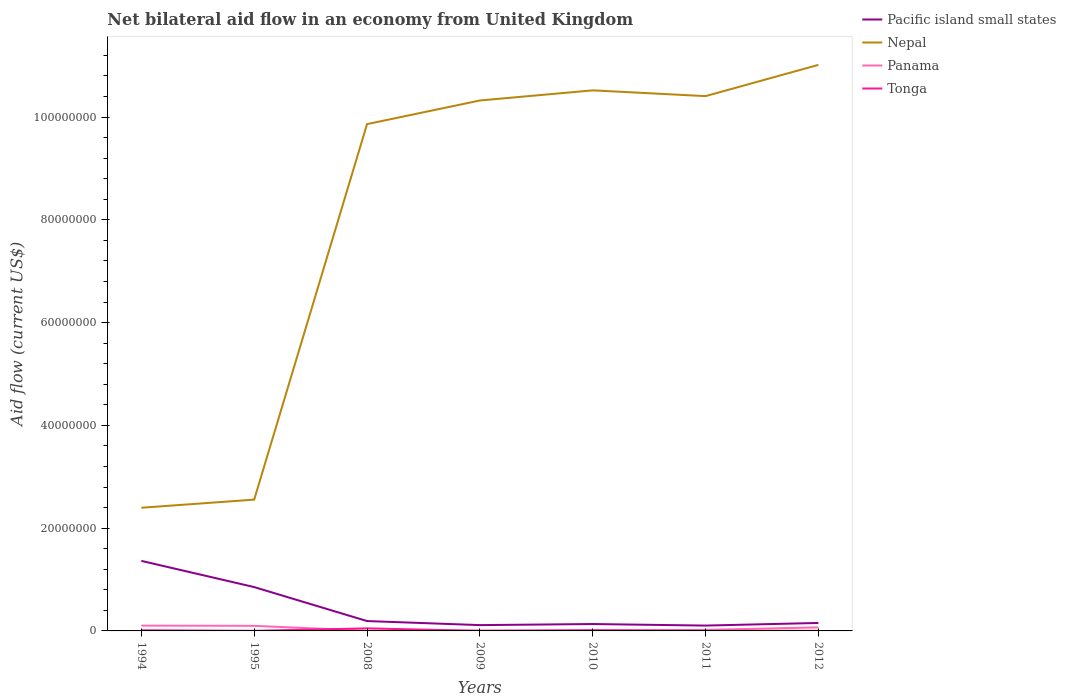Is the number of lines equal to the number of legend labels?
Provide a short and direct response. Yes. Across all years, what is the maximum net bilateral aid flow in Nepal?
Your answer should be compact. 2.40e+07. What is the total net bilateral aid flow in Tonga in the graph?
Ensure brevity in your answer.  4.90e+05. Is the net bilateral aid flow in Panama strictly greater than the net bilateral aid flow in Nepal over the years?
Make the answer very short. Yes. How many years are there in the graph?
Provide a short and direct response. 7. Does the graph contain any zero values?
Provide a short and direct response. No. Does the graph contain grids?
Your answer should be very brief. No. How many legend labels are there?
Your response must be concise. 4. What is the title of the graph?
Offer a terse response. Net bilateral aid flow in an economy from United Kingdom. What is the label or title of the Y-axis?
Ensure brevity in your answer.  Aid flow (current US$). What is the Aid flow (current US$) of Pacific island small states in 1994?
Your response must be concise. 1.36e+07. What is the Aid flow (current US$) of Nepal in 1994?
Give a very brief answer. 2.40e+07. What is the Aid flow (current US$) of Panama in 1994?
Give a very brief answer. 1.03e+06. What is the Aid flow (current US$) of Pacific island small states in 1995?
Your response must be concise. 8.53e+06. What is the Aid flow (current US$) of Nepal in 1995?
Provide a short and direct response. 2.56e+07. What is the Aid flow (current US$) in Panama in 1995?
Offer a very short reply. 9.90e+05. What is the Aid flow (current US$) in Tonga in 1995?
Make the answer very short. 2.00e+04. What is the Aid flow (current US$) of Pacific island small states in 2008?
Ensure brevity in your answer.  1.92e+06. What is the Aid flow (current US$) of Nepal in 2008?
Make the answer very short. 9.86e+07. What is the Aid flow (current US$) in Pacific island small states in 2009?
Your answer should be compact. 1.13e+06. What is the Aid flow (current US$) of Nepal in 2009?
Ensure brevity in your answer.  1.03e+08. What is the Aid flow (current US$) of Panama in 2009?
Ensure brevity in your answer.  7.00e+04. What is the Aid flow (current US$) in Tonga in 2009?
Provide a short and direct response. 10000. What is the Aid flow (current US$) in Pacific island small states in 2010?
Give a very brief answer. 1.34e+06. What is the Aid flow (current US$) of Nepal in 2010?
Provide a short and direct response. 1.05e+08. What is the Aid flow (current US$) of Panama in 2010?
Provide a succinct answer. 4.00e+04. What is the Aid flow (current US$) of Tonga in 2010?
Your answer should be very brief. 1.50e+05. What is the Aid flow (current US$) in Pacific island small states in 2011?
Offer a terse response. 1.04e+06. What is the Aid flow (current US$) of Nepal in 2011?
Offer a terse response. 1.04e+08. What is the Aid flow (current US$) of Tonga in 2011?
Make the answer very short. 3.00e+04. What is the Aid flow (current US$) in Pacific island small states in 2012?
Provide a succinct answer. 1.55e+06. What is the Aid flow (current US$) in Nepal in 2012?
Your answer should be very brief. 1.10e+08. What is the Aid flow (current US$) of Panama in 2012?
Offer a very short reply. 6.90e+05. What is the Aid flow (current US$) of Tonga in 2012?
Keep it short and to the point. 3.00e+04. Across all years, what is the maximum Aid flow (current US$) in Pacific island small states?
Keep it short and to the point. 1.36e+07. Across all years, what is the maximum Aid flow (current US$) of Nepal?
Ensure brevity in your answer.  1.10e+08. Across all years, what is the maximum Aid flow (current US$) in Panama?
Your response must be concise. 1.03e+06. Across all years, what is the maximum Aid flow (current US$) in Tonga?
Offer a terse response. 5.00e+05. Across all years, what is the minimum Aid flow (current US$) of Pacific island small states?
Offer a terse response. 1.04e+06. Across all years, what is the minimum Aid flow (current US$) of Nepal?
Your response must be concise. 2.40e+07. Across all years, what is the minimum Aid flow (current US$) in Panama?
Offer a very short reply. 4.00e+04. What is the total Aid flow (current US$) of Pacific island small states in the graph?
Provide a succinct answer. 2.91e+07. What is the total Aid flow (current US$) in Nepal in the graph?
Offer a very short reply. 5.71e+08. What is the total Aid flow (current US$) of Panama in the graph?
Your answer should be very brief. 3.06e+06. What is the total Aid flow (current US$) of Tonga in the graph?
Provide a succinct answer. 8.70e+05. What is the difference between the Aid flow (current US$) in Pacific island small states in 1994 and that in 1995?
Ensure brevity in your answer.  5.10e+06. What is the difference between the Aid flow (current US$) in Nepal in 1994 and that in 1995?
Your response must be concise. -1.58e+06. What is the difference between the Aid flow (current US$) of Pacific island small states in 1994 and that in 2008?
Make the answer very short. 1.17e+07. What is the difference between the Aid flow (current US$) in Nepal in 1994 and that in 2008?
Offer a very short reply. -7.46e+07. What is the difference between the Aid flow (current US$) of Panama in 1994 and that in 2008?
Provide a short and direct response. 9.90e+05. What is the difference between the Aid flow (current US$) of Tonga in 1994 and that in 2008?
Your answer should be compact. -3.70e+05. What is the difference between the Aid flow (current US$) in Pacific island small states in 1994 and that in 2009?
Ensure brevity in your answer.  1.25e+07. What is the difference between the Aid flow (current US$) in Nepal in 1994 and that in 2009?
Your answer should be compact. -7.92e+07. What is the difference between the Aid flow (current US$) of Panama in 1994 and that in 2009?
Give a very brief answer. 9.60e+05. What is the difference between the Aid flow (current US$) in Pacific island small states in 1994 and that in 2010?
Your answer should be very brief. 1.23e+07. What is the difference between the Aid flow (current US$) in Nepal in 1994 and that in 2010?
Make the answer very short. -8.12e+07. What is the difference between the Aid flow (current US$) of Panama in 1994 and that in 2010?
Make the answer very short. 9.90e+05. What is the difference between the Aid flow (current US$) of Tonga in 1994 and that in 2010?
Your response must be concise. -2.00e+04. What is the difference between the Aid flow (current US$) of Pacific island small states in 1994 and that in 2011?
Ensure brevity in your answer.  1.26e+07. What is the difference between the Aid flow (current US$) in Nepal in 1994 and that in 2011?
Offer a terse response. -8.01e+07. What is the difference between the Aid flow (current US$) of Panama in 1994 and that in 2011?
Offer a very short reply. 8.30e+05. What is the difference between the Aid flow (current US$) of Tonga in 1994 and that in 2011?
Ensure brevity in your answer.  1.00e+05. What is the difference between the Aid flow (current US$) of Pacific island small states in 1994 and that in 2012?
Provide a succinct answer. 1.21e+07. What is the difference between the Aid flow (current US$) in Nepal in 1994 and that in 2012?
Your answer should be compact. -8.62e+07. What is the difference between the Aid flow (current US$) in Pacific island small states in 1995 and that in 2008?
Provide a succinct answer. 6.61e+06. What is the difference between the Aid flow (current US$) in Nepal in 1995 and that in 2008?
Provide a short and direct response. -7.31e+07. What is the difference between the Aid flow (current US$) of Panama in 1995 and that in 2008?
Make the answer very short. 9.50e+05. What is the difference between the Aid flow (current US$) in Tonga in 1995 and that in 2008?
Ensure brevity in your answer.  -4.80e+05. What is the difference between the Aid flow (current US$) in Pacific island small states in 1995 and that in 2009?
Keep it short and to the point. 7.40e+06. What is the difference between the Aid flow (current US$) of Nepal in 1995 and that in 2009?
Make the answer very short. -7.77e+07. What is the difference between the Aid flow (current US$) in Panama in 1995 and that in 2009?
Keep it short and to the point. 9.20e+05. What is the difference between the Aid flow (current US$) in Pacific island small states in 1995 and that in 2010?
Your answer should be compact. 7.19e+06. What is the difference between the Aid flow (current US$) in Nepal in 1995 and that in 2010?
Provide a succinct answer. -7.96e+07. What is the difference between the Aid flow (current US$) in Panama in 1995 and that in 2010?
Give a very brief answer. 9.50e+05. What is the difference between the Aid flow (current US$) of Tonga in 1995 and that in 2010?
Offer a very short reply. -1.30e+05. What is the difference between the Aid flow (current US$) of Pacific island small states in 1995 and that in 2011?
Your response must be concise. 7.49e+06. What is the difference between the Aid flow (current US$) of Nepal in 1995 and that in 2011?
Your answer should be very brief. -7.85e+07. What is the difference between the Aid flow (current US$) in Panama in 1995 and that in 2011?
Your answer should be compact. 7.90e+05. What is the difference between the Aid flow (current US$) in Pacific island small states in 1995 and that in 2012?
Make the answer very short. 6.98e+06. What is the difference between the Aid flow (current US$) in Nepal in 1995 and that in 2012?
Offer a terse response. -8.46e+07. What is the difference between the Aid flow (current US$) in Panama in 1995 and that in 2012?
Offer a very short reply. 3.00e+05. What is the difference between the Aid flow (current US$) in Tonga in 1995 and that in 2012?
Provide a succinct answer. -10000. What is the difference between the Aid flow (current US$) of Pacific island small states in 2008 and that in 2009?
Your response must be concise. 7.90e+05. What is the difference between the Aid flow (current US$) of Nepal in 2008 and that in 2009?
Your answer should be compact. -4.60e+06. What is the difference between the Aid flow (current US$) in Tonga in 2008 and that in 2009?
Keep it short and to the point. 4.90e+05. What is the difference between the Aid flow (current US$) in Pacific island small states in 2008 and that in 2010?
Give a very brief answer. 5.80e+05. What is the difference between the Aid flow (current US$) in Nepal in 2008 and that in 2010?
Keep it short and to the point. -6.57e+06. What is the difference between the Aid flow (current US$) in Tonga in 2008 and that in 2010?
Offer a terse response. 3.50e+05. What is the difference between the Aid flow (current US$) in Pacific island small states in 2008 and that in 2011?
Offer a very short reply. 8.80e+05. What is the difference between the Aid flow (current US$) in Nepal in 2008 and that in 2011?
Provide a succinct answer. -5.45e+06. What is the difference between the Aid flow (current US$) in Nepal in 2008 and that in 2012?
Provide a succinct answer. -1.15e+07. What is the difference between the Aid flow (current US$) in Panama in 2008 and that in 2012?
Give a very brief answer. -6.50e+05. What is the difference between the Aid flow (current US$) in Pacific island small states in 2009 and that in 2010?
Keep it short and to the point. -2.10e+05. What is the difference between the Aid flow (current US$) in Nepal in 2009 and that in 2010?
Your answer should be very brief. -1.97e+06. What is the difference between the Aid flow (current US$) in Pacific island small states in 2009 and that in 2011?
Ensure brevity in your answer.  9.00e+04. What is the difference between the Aid flow (current US$) of Nepal in 2009 and that in 2011?
Your response must be concise. -8.50e+05. What is the difference between the Aid flow (current US$) in Panama in 2009 and that in 2011?
Offer a terse response. -1.30e+05. What is the difference between the Aid flow (current US$) of Tonga in 2009 and that in 2011?
Make the answer very short. -2.00e+04. What is the difference between the Aid flow (current US$) of Pacific island small states in 2009 and that in 2012?
Keep it short and to the point. -4.20e+05. What is the difference between the Aid flow (current US$) of Nepal in 2009 and that in 2012?
Your response must be concise. -6.93e+06. What is the difference between the Aid flow (current US$) in Panama in 2009 and that in 2012?
Keep it short and to the point. -6.20e+05. What is the difference between the Aid flow (current US$) of Tonga in 2009 and that in 2012?
Offer a very short reply. -2.00e+04. What is the difference between the Aid flow (current US$) of Nepal in 2010 and that in 2011?
Your answer should be compact. 1.12e+06. What is the difference between the Aid flow (current US$) in Panama in 2010 and that in 2011?
Keep it short and to the point. -1.60e+05. What is the difference between the Aid flow (current US$) in Tonga in 2010 and that in 2011?
Make the answer very short. 1.20e+05. What is the difference between the Aid flow (current US$) of Pacific island small states in 2010 and that in 2012?
Offer a very short reply. -2.10e+05. What is the difference between the Aid flow (current US$) of Nepal in 2010 and that in 2012?
Your answer should be compact. -4.96e+06. What is the difference between the Aid flow (current US$) of Panama in 2010 and that in 2012?
Provide a succinct answer. -6.50e+05. What is the difference between the Aid flow (current US$) in Pacific island small states in 2011 and that in 2012?
Give a very brief answer. -5.10e+05. What is the difference between the Aid flow (current US$) of Nepal in 2011 and that in 2012?
Make the answer very short. -6.08e+06. What is the difference between the Aid flow (current US$) in Panama in 2011 and that in 2012?
Ensure brevity in your answer.  -4.90e+05. What is the difference between the Aid flow (current US$) of Tonga in 2011 and that in 2012?
Offer a terse response. 0. What is the difference between the Aid flow (current US$) of Pacific island small states in 1994 and the Aid flow (current US$) of Nepal in 1995?
Give a very brief answer. -1.19e+07. What is the difference between the Aid flow (current US$) in Pacific island small states in 1994 and the Aid flow (current US$) in Panama in 1995?
Make the answer very short. 1.26e+07. What is the difference between the Aid flow (current US$) of Pacific island small states in 1994 and the Aid flow (current US$) of Tonga in 1995?
Keep it short and to the point. 1.36e+07. What is the difference between the Aid flow (current US$) of Nepal in 1994 and the Aid flow (current US$) of Panama in 1995?
Provide a short and direct response. 2.30e+07. What is the difference between the Aid flow (current US$) in Nepal in 1994 and the Aid flow (current US$) in Tonga in 1995?
Make the answer very short. 2.40e+07. What is the difference between the Aid flow (current US$) in Panama in 1994 and the Aid flow (current US$) in Tonga in 1995?
Offer a terse response. 1.01e+06. What is the difference between the Aid flow (current US$) in Pacific island small states in 1994 and the Aid flow (current US$) in Nepal in 2008?
Offer a terse response. -8.50e+07. What is the difference between the Aid flow (current US$) in Pacific island small states in 1994 and the Aid flow (current US$) in Panama in 2008?
Your answer should be very brief. 1.36e+07. What is the difference between the Aid flow (current US$) in Pacific island small states in 1994 and the Aid flow (current US$) in Tonga in 2008?
Give a very brief answer. 1.31e+07. What is the difference between the Aid flow (current US$) in Nepal in 1994 and the Aid flow (current US$) in Panama in 2008?
Make the answer very short. 2.39e+07. What is the difference between the Aid flow (current US$) in Nepal in 1994 and the Aid flow (current US$) in Tonga in 2008?
Offer a very short reply. 2.35e+07. What is the difference between the Aid flow (current US$) of Panama in 1994 and the Aid flow (current US$) of Tonga in 2008?
Make the answer very short. 5.30e+05. What is the difference between the Aid flow (current US$) of Pacific island small states in 1994 and the Aid flow (current US$) of Nepal in 2009?
Your answer should be very brief. -8.96e+07. What is the difference between the Aid flow (current US$) of Pacific island small states in 1994 and the Aid flow (current US$) of Panama in 2009?
Ensure brevity in your answer.  1.36e+07. What is the difference between the Aid flow (current US$) in Pacific island small states in 1994 and the Aid flow (current US$) in Tonga in 2009?
Your answer should be very brief. 1.36e+07. What is the difference between the Aid flow (current US$) in Nepal in 1994 and the Aid flow (current US$) in Panama in 2009?
Ensure brevity in your answer.  2.39e+07. What is the difference between the Aid flow (current US$) of Nepal in 1994 and the Aid flow (current US$) of Tonga in 2009?
Your answer should be very brief. 2.40e+07. What is the difference between the Aid flow (current US$) in Panama in 1994 and the Aid flow (current US$) in Tonga in 2009?
Give a very brief answer. 1.02e+06. What is the difference between the Aid flow (current US$) of Pacific island small states in 1994 and the Aid flow (current US$) of Nepal in 2010?
Keep it short and to the point. -9.16e+07. What is the difference between the Aid flow (current US$) of Pacific island small states in 1994 and the Aid flow (current US$) of Panama in 2010?
Provide a succinct answer. 1.36e+07. What is the difference between the Aid flow (current US$) of Pacific island small states in 1994 and the Aid flow (current US$) of Tonga in 2010?
Your response must be concise. 1.35e+07. What is the difference between the Aid flow (current US$) of Nepal in 1994 and the Aid flow (current US$) of Panama in 2010?
Provide a succinct answer. 2.39e+07. What is the difference between the Aid flow (current US$) of Nepal in 1994 and the Aid flow (current US$) of Tonga in 2010?
Offer a very short reply. 2.38e+07. What is the difference between the Aid flow (current US$) of Panama in 1994 and the Aid flow (current US$) of Tonga in 2010?
Make the answer very short. 8.80e+05. What is the difference between the Aid flow (current US$) of Pacific island small states in 1994 and the Aid flow (current US$) of Nepal in 2011?
Provide a succinct answer. -9.04e+07. What is the difference between the Aid flow (current US$) in Pacific island small states in 1994 and the Aid flow (current US$) in Panama in 2011?
Keep it short and to the point. 1.34e+07. What is the difference between the Aid flow (current US$) of Pacific island small states in 1994 and the Aid flow (current US$) of Tonga in 2011?
Provide a succinct answer. 1.36e+07. What is the difference between the Aid flow (current US$) in Nepal in 1994 and the Aid flow (current US$) in Panama in 2011?
Provide a short and direct response. 2.38e+07. What is the difference between the Aid flow (current US$) in Nepal in 1994 and the Aid flow (current US$) in Tonga in 2011?
Provide a succinct answer. 2.39e+07. What is the difference between the Aid flow (current US$) in Pacific island small states in 1994 and the Aid flow (current US$) in Nepal in 2012?
Offer a terse response. -9.65e+07. What is the difference between the Aid flow (current US$) in Pacific island small states in 1994 and the Aid flow (current US$) in Panama in 2012?
Provide a succinct answer. 1.29e+07. What is the difference between the Aid flow (current US$) in Pacific island small states in 1994 and the Aid flow (current US$) in Tonga in 2012?
Offer a very short reply. 1.36e+07. What is the difference between the Aid flow (current US$) in Nepal in 1994 and the Aid flow (current US$) in Panama in 2012?
Keep it short and to the point. 2.33e+07. What is the difference between the Aid flow (current US$) in Nepal in 1994 and the Aid flow (current US$) in Tonga in 2012?
Offer a very short reply. 2.39e+07. What is the difference between the Aid flow (current US$) in Pacific island small states in 1995 and the Aid flow (current US$) in Nepal in 2008?
Offer a terse response. -9.01e+07. What is the difference between the Aid flow (current US$) in Pacific island small states in 1995 and the Aid flow (current US$) in Panama in 2008?
Offer a very short reply. 8.49e+06. What is the difference between the Aid flow (current US$) in Pacific island small states in 1995 and the Aid flow (current US$) in Tonga in 2008?
Give a very brief answer. 8.03e+06. What is the difference between the Aid flow (current US$) in Nepal in 1995 and the Aid flow (current US$) in Panama in 2008?
Provide a short and direct response. 2.55e+07. What is the difference between the Aid flow (current US$) in Nepal in 1995 and the Aid flow (current US$) in Tonga in 2008?
Offer a very short reply. 2.50e+07. What is the difference between the Aid flow (current US$) in Pacific island small states in 1995 and the Aid flow (current US$) in Nepal in 2009?
Provide a short and direct response. -9.47e+07. What is the difference between the Aid flow (current US$) of Pacific island small states in 1995 and the Aid flow (current US$) of Panama in 2009?
Offer a terse response. 8.46e+06. What is the difference between the Aid flow (current US$) of Pacific island small states in 1995 and the Aid flow (current US$) of Tonga in 2009?
Provide a succinct answer. 8.52e+06. What is the difference between the Aid flow (current US$) in Nepal in 1995 and the Aid flow (current US$) in Panama in 2009?
Make the answer very short. 2.55e+07. What is the difference between the Aid flow (current US$) in Nepal in 1995 and the Aid flow (current US$) in Tonga in 2009?
Your answer should be compact. 2.55e+07. What is the difference between the Aid flow (current US$) of Panama in 1995 and the Aid flow (current US$) of Tonga in 2009?
Offer a very short reply. 9.80e+05. What is the difference between the Aid flow (current US$) of Pacific island small states in 1995 and the Aid flow (current US$) of Nepal in 2010?
Your response must be concise. -9.67e+07. What is the difference between the Aid flow (current US$) in Pacific island small states in 1995 and the Aid flow (current US$) in Panama in 2010?
Your response must be concise. 8.49e+06. What is the difference between the Aid flow (current US$) of Pacific island small states in 1995 and the Aid flow (current US$) of Tonga in 2010?
Give a very brief answer. 8.38e+06. What is the difference between the Aid flow (current US$) in Nepal in 1995 and the Aid flow (current US$) in Panama in 2010?
Offer a very short reply. 2.55e+07. What is the difference between the Aid flow (current US$) of Nepal in 1995 and the Aid flow (current US$) of Tonga in 2010?
Provide a short and direct response. 2.54e+07. What is the difference between the Aid flow (current US$) of Panama in 1995 and the Aid flow (current US$) of Tonga in 2010?
Ensure brevity in your answer.  8.40e+05. What is the difference between the Aid flow (current US$) of Pacific island small states in 1995 and the Aid flow (current US$) of Nepal in 2011?
Offer a terse response. -9.55e+07. What is the difference between the Aid flow (current US$) in Pacific island small states in 1995 and the Aid flow (current US$) in Panama in 2011?
Give a very brief answer. 8.33e+06. What is the difference between the Aid flow (current US$) of Pacific island small states in 1995 and the Aid flow (current US$) of Tonga in 2011?
Make the answer very short. 8.50e+06. What is the difference between the Aid flow (current US$) of Nepal in 1995 and the Aid flow (current US$) of Panama in 2011?
Keep it short and to the point. 2.54e+07. What is the difference between the Aid flow (current US$) in Nepal in 1995 and the Aid flow (current US$) in Tonga in 2011?
Offer a very short reply. 2.55e+07. What is the difference between the Aid flow (current US$) in Panama in 1995 and the Aid flow (current US$) in Tonga in 2011?
Your answer should be compact. 9.60e+05. What is the difference between the Aid flow (current US$) of Pacific island small states in 1995 and the Aid flow (current US$) of Nepal in 2012?
Offer a very short reply. -1.02e+08. What is the difference between the Aid flow (current US$) of Pacific island small states in 1995 and the Aid flow (current US$) of Panama in 2012?
Provide a short and direct response. 7.84e+06. What is the difference between the Aid flow (current US$) in Pacific island small states in 1995 and the Aid flow (current US$) in Tonga in 2012?
Make the answer very short. 8.50e+06. What is the difference between the Aid flow (current US$) in Nepal in 1995 and the Aid flow (current US$) in Panama in 2012?
Offer a very short reply. 2.49e+07. What is the difference between the Aid flow (current US$) of Nepal in 1995 and the Aid flow (current US$) of Tonga in 2012?
Your response must be concise. 2.55e+07. What is the difference between the Aid flow (current US$) of Panama in 1995 and the Aid flow (current US$) of Tonga in 2012?
Offer a very short reply. 9.60e+05. What is the difference between the Aid flow (current US$) in Pacific island small states in 2008 and the Aid flow (current US$) in Nepal in 2009?
Keep it short and to the point. -1.01e+08. What is the difference between the Aid flow (current US$) of Pacific island small states in 2008 and the Aid flow (current US$) of Panama in 2009?
Your answer should be very brief. 1.85e+06. What is the difference between the Aid flow (current US$) in Pacific island small states in 2008 and the Aid flow (current US$) in Tonga in 2009?
Make the answer very short. 1.91e+06. What is the difference between the Aid flow (current US$) of Nepal in 2008 and the Aid flow (current US$) of Panama in 2009?
Your response must be concise. 9.86e+07. What is the difference between the Aid flow (current US$) in Nepal in 2008 and the Aid flow (current US$) in Tonga in 2009?
Your answer should be compact. 9.86e+07. What is the difference between the Aid flow (current US$) in Panama in 2008 and the Aid flow (current US$) in Tonga in 2009?
Provide a succinct answer. 3.00e+04. What is the difference between the Aid flow (current US$) in Pacific island small states in 2008 and the Aid flow (current US$) in Nepal in 2010?
Provide a short and direct response. -1.03e+08. What is the difference between the Aid flow (current US$) of Pacific island small states in 2008 and the Aid flow (current US$) of Panama in 2010?
Keep it short and to the point. 1.88e+06. What is the difference between the Aid flow (current US$) of Pacific island small states in 2008 and the Aid flow (current US$) of Tonga in 2010?
Your response must be concise. 1.77e+06. What is the difference between the Aid flow (current US$) in Nepal in 2008 and the Aid flow (current US$) in Panama in 2010?
Your answer should be compact. 9.86e+07. What is the difference between the Aid flow (current US$) of Nepal in 2008 and the Aid flow (current US$) of Tonga in 2010?
Your response must be concise. 9.85e+07. What is the difference between the Aid flow (current US$) in Panama in 2008 and the Aid flow (current US$) in Tonga in 2010?
Offer a terse response. -1.10e+05. What is the difference between the Aid flow (current US$) of Pacific island small states in 2008 and the Aid flow (current US$) of Nepal in 2011?
Make the answer very short. -1.02e+08. What is the difference between the Aid flow (current US$) in Pacific island small states in 2008 and the Aid flow (current US$) in Panama in 2011?
Offer a very short reply. 1.72e+06. What is the difference between the Aid flow (current US$) of Pacific island small states in 2008 and the Aid flow (current US$) of Tonga in 2011?
Offer a very short reply. 1.89e+06. What is the difference between the Aid flow (current US$) in Nepal in 2008 and the Aid flow (current US$) in Panama in 2011?
Your answer should be very brief. 9.84e+07. What is the difference between the Aid flow (current US$) of Nepal in 2008 and the Aid flow (current US$) of Tonga in 2011?
Your answer should be very brief. 9.86e+07. What is the difference between the Aid flow (current US$) of Panama in 2008 and the Aid flow (current US$) of Tonga in 2011?
Your response must be concise. 10000. What is the difference between the Aid flow (current US$) of Pacific island small states in 2008 and the Aid flow (current US$) of Nepal in 2012?
Your response must be concise. -1.08e+08. What is the difference between the Aid flow (current US$) in Pacific island small states in 2008 and the Aid flow (current US$) in Panama in 2012?
Your answer should be very brief. 1.23e+06. What is the difference between the Aid flow (current US$) in Pacific island small states in 2008 and the Aid flow (current US$) in Tonga in 2012?
Provide a succinct answer. 1.89e+06. What is the difference between the Aid flow (current US$) in Nepal in 2008 and the Aid flow (current US$) in Panama in 2012?
Give a very brief answer. 9.79e+07. What is the difference between the Aid flow (current US$) of Nepal in 2008 and the Aid flow (current US$) of Tonga in 2012?
Provide a short and direct response. 9.86e+07. What is the difference between the Aid flow (current US$) of Pacific island small states in 2009 and the Aid flow (current US$) of Nepal in 2010?
Keep it short and to the point. -1.04e+08. What is the difference between the Aid flow (current US$) of Pacific island small states in 2009 and the Aid flow (current US$) of Panama in 2010?
Your answer should be very brief. 1.09e+06. What is the difference between the Aid flow (current US$) in Pacific island small states in 2009 and the Aid flow (current US$) in Tonga in 2010?
Your answer should be compact. 9.80e+05. What is the difference between the Aid flow (current US$) in Nepal in 2009 and the Aid flow (current US$) in Panama in 2010?
Make the answer very short. 1.03e+08. What is the difference between the Aid flow (current US$) in Nepal in 2009 and the Aid flow (current US$) in Tonga in 2010?
Ensure brevity in your answer.  1.03e+08. What is the difference between the Aid flow (current US$) in Pacific island small states in 2009 and the Aid flow (current US$) in Nepal in 2011?
Your response must be concise. -1.03e+08. What is the difference between the Aid flow (current US$) of Pacific island small states in 2009 and the Aid flow (current US$) of Panama in 2011?
Provide a short and direct response. 9.30e+05. What is the difference between the Aid flow (current US$) of Pacific island small states in 2009 and the Aid flow (current US$) of Tonga in 2011?
Your answer should be very brief. 1.10e+06. What is the difference between the Aid flow (current US$) of Nepal in 2009 and the Aid flow (current US$) of Panama in 2011?
Provide a succinct answer. 1.03e+08. What is the difference between the Aid flow (current US$) of Nepal in 2009 and the Aid flow (current US$) of Tonga in 2011?
Your response must be concise. 1.03e+08. What is the difference between the Aid flow (current US$) in Pacific island small states in 2009 and the Aid flow (current US$) in Nepal in 2012?
Your answer should be very brief. -1.09e+08. What is the difference between the Aid flow (current US$) of Pacific island small states in 2009 and the Aid flow (current US$) of Tonga in 2012?
Make the answer very short. 1.10e+06. What is the difference between the Aid flow (current US$) in Nepal in 2009 and the Aid flow (current US$) in Panama in 2012?
Offer a very short reply. 1.03e+08. What is the difference between the Aid flow (current US$) in Nepal in 2009 and the Aid flow (current US$) in Tonga in 2012?
Provide a short and direct response. 1.03e+08. What is the difference between the Aid flow (current US$) in Pacific island small states in 2010 and the Aid flow (current US$) in Nepal in 2011?
Provide a short and direct response. -1.03e+08. What is the difference between the Aid flow (current US$) in Pacific island small states in 2010 and the Aid flow (current US$) in Panama in 2011?
Give a very brief answer. 1.14e+06. What is the difference between the Aid flow (current US$) of Pacific island small states in 2010 and the Aid flow (current US$) of Tonga in 2011?
Your answer should be very brief. 1.31e+06. What is the difference between the Aid flow (current US$) in Nepal in 2010 and the Aid flow (current US$) in Panama in 2011?
Offer a very short reply. 1.05e+08. What is the difference between the Aid flow (current US$) in Nepal in 2010 and the Aid flow (current US$) in Tonga in 2011?
Ensure brevity in your answer.  1.05e+08. What is the difference between the Aid flow (current US$) of Pacific island small states in 2010 and the Aid flow (current US$) of Nepal in 2012?
Offer a terse response. -1.09e+08. What is the difference between the Aid flow (current US$) in Pacific island small states in 2010 and the Aid flow (current US$) in Panama in 2012?
Your response must be concise. 6.50e+05. What is the difference between the Aid flow (current US$) in Pacific island small states in 2010 and the Aid flow (current US$) in Tonga in 2012?
Your answer should be compact. 1.31e+06. What is the difference between the Aid flow (current US$) in Nepal in 2010 and the Aid flow (current US$) in Panama in 2012?
Offer a very short reply. 1.04e+08. What is the difference between the Aid flow (current US$) in Nepal in 2010 and the Aid flow (current US$) in Tonga in 2012?
Keep it short and to the point. 1.05e+08. What is the difference between the Aid flow (current US$) of Panama in 2010 and the Aid flow (current US$) of Tonga in 2012?
Your answer should be compact. 10000. What is the difference between the Aid flow (current US$) of Pacific island small states in 2011 and the Aid flow (current US$) of Nepal in 2012?
Your response must be concise. -1.09e+08. What is the difference between the Aid flow (current US$) of Pacific island small states in 2011 and the Aid flow (current US$) of Panama in 2012?
Provide a short and direct response. 3.50e+05. What is the difference between the Aid flow (current US$) of Pacific island small states in 2011 and the Aid flow (current US$) of Tonga in 2012?
Give a very brief answer. 1.01e+06. What is the difference between the Aid flow (current US$) in Nepal in 2011 and the Aid flow (current US$) in Panama in 2012?
Make the answer very short. 1.03e+08. What is the difference between the Aid flow (current US$) in Nepal in 2011 and the Aid flow (current US$) in Tonga in 2012?
Offer a very short reply. 1.04e+08. What is the average Aid flow (current US$) in Pacific island small states per year?
Keep it short and to the point. 4.16e+06. What is the average Aid flow (current US$) in Nepal per year?
Provide a short and direct response. 8.15e+07. What is the average Aid flow (current US$) in Panama per year?
Ensure brevity in your answer.  4.37e+05. What is the average Aid flow (current US$) of Tonga per year?
Offer a terse response. 1.24e+05. In the year 1994, what is the difference between the Aid flow (current US$) in Pacific island small states and Aid flow (current US$) in Nepal?
Offer a very short reply. -1.03e+07. In the year 1994, what is the difference between the Aid flow (current US$) of Pacific island small states and Aid flow (current US$) of Panama?
Provide a succinct answer. 1.26e+07. In the year 1994, what is the difference between the Aid flow (current US$) in Pacific island small states and Aid flow (current US$) in Tonga?
Provide a succinct answer. 1.35e+07. In the year 1994, what is the difference between the Aid flow (current US$) of Nepal and Aid flow (current US$) of Panama?
Make the answer very short. 2.29e+07. In the year 1994, what is the difference between the Aid flow (current US$) in Nepal and Aid flow (current US$) in Tonga?
Give a very brief answer. 2.38e+07. In the year 1995, what is the difference between the Aid flow (current US$) of Pacific island small states and Aid flow (current US$) of Nepal?
Keep it short and to the point. -1.70e+07. In the year 1995, what is the difference between the Aid flow (current US$) of Pacific island small states and Aid flow (current US$) of Panama?
Ensure brevity in your answer.  7.54e+06. In the year 1995, what is the difference between the Aid flow (current US$) in Pacific island small states and Aid flow (current US$) in Tonga?
Provide a succinct answer. 8.51e+06. In the year 1995, what is the difference between the Aid flow (current US$) of Nepal and Aid flow (current US$) of Panama?
Your answer should be compact. 2.46e+07. In the year 1995, what is the difference between the Aid flow (current US$) of Nepal and Aid flow (current US$) of Tonga?
Offer a very short reply. 2.55e+07. In the year 1995, what is the difference between the Aid flow (current US$) in Panama and Aid flow (current US$) in Tonga?
Provide a short and direct response. 9.70e+05. In the year 2008, what is the difference between the Aid flow (current US$) in Pacific island small states and Aid flow (current US$) in Nepal?
Keep it short and to the point. -9.67e+07. In the year 2008, what is the difference between the Aid flow (current US$) in Pacific island small states and Aid flow (current US$) in Panama?
Offer a very short reply. 1.88e+06. In the year 2008, what is the difference between the Aid flow (current US$) in Pacific island small states and Aid flow (current US$) in Tonga?
Provide a short and direct response. 1.42e+06. In the year 2008, what is the difference between the Aid flow (current US$) of Nepal and Aid flow (current US$) of Panama?
Provide a short and direct response. 9.86e+07. In the year 2008, what is the difference between the Aid flow (current US$) of Nepal and Aid flow (current US$) of Tonga?
Provide a succinct answer. 9.81e+07. In the year 2008, what is the difference between the Aid flow (current US$) in Panama and Aid flow (current US$) in Tonga?
Offer a terse response. -4.60e+05. In the year 2009, what is the difference between the Aid flow (current US$) of Pacific island small states and Aid flow (current US$) of Nepal?
Your answer should be very brief. -1.02e+08. In the year 2009, what is the difference between the Aid flow (current US$) in Pacific island small states and Aid flow (current US$) in Panama?
Make the answer very short. 1.06e+06. In the year 2009, what is the difference between the Aid flow (current US$) of Pacific island small states and Aid flow (current US$) of Tonga?
Keep it short and to the point. 1.12e+06. In the year 2009, what is the difference between the Aid flow (current US$) in Nepal and Aid flow (current US$) in Panama?
Your answer should be very brief. 1.03e+08. In the year 2009, what is the difference between the Aid flow (current US$) in Nepal and Aid flow (current US$) in Tonga?
Your answer should be very brief. 1.03e+08. In the year 2010, what is the difference between the Aid flow (current US$) in Pacific island small states and Aid flow (current US$) in Nepal?
Your answer should be very brief. -1.04e+08. In the year 2010, what is the difference between the Aid flow (current US$) of Pacific island small states and Aid flow (current US$) of Panama?
Give a very brief answer. 1.30e+06. In the year 2010, what is the difference between the Aid flow (current US$) in Pacific island small states and Aid flow (current US$) in Tonga?
Ensure brevity in your answer.  1.19e+06. In the year 2010, what is the difference between the Aid flow (current US$) of Nepal and Aid flow (current US$) of Panama?
Offer a very short reply. 1.05e+08. In the year 2010, what is the difference between the Aid flow (current US$) in Nepal and Aid flow (current US$) in Tonga?
Offer a very short reply. 1.05e+08. In the year 2011, what is the difference between the Aid flow (current US$) in Pacific island small states and Aid flow (current US$) in Nepal?
Your answer should be compact. -1.03e+08. In the year 2011, what is the difference between the Aid flow (current US$) in Pacific island small states and Aid flow (current US$) in Panama?
Make the answer very short. 8.40e+05. In the year 2011, what is the difference between the Aid flow (current US$) in Pacific island small states and Aid flow (current US$) in Tonga?
Offer a very short reply. 1.01e+06. In the year 2011, what is the difference between the Aid flow (current US$) in Nepal and Aid flow (current US$) in Panama?
Offer a very short reply. 1.04e+08. In the year 2011, what is the difference between the Aid flow (current US$) in Nepal and Aid flow (current US$) in Tonga?
Your response must be concise. 1.04e+08. In the year 2012, what is the difference between the Aid flow (current US$) in Pacific island small states and Aid flow (current US$) in Nepal?
Your response must be concise. -1.09e+08. In the year 2012, what is the difference between the Aid flow (current US$) in Pacific island small states and Aid flow (current US$) in Panama?
Make the answer very short. 8.60e+05. In the year 2012, what is the difference between the Aid flow (current US$) of Pacific island small states and Aid flow (current US$) of Tonga?
Offer a very short reply. 1.52e+06. In the year 2012, what is the difference between the Aid flow (current US$) of Nepal and Aid flow (current US$) of Panama?
Ensure brevity in your answer.  1.09e+08. In the year 2012, what is the difference between the Aid flow (current US$) of Nepal and Aid flow (current US$) of Tonga?
Offer a very short reply. 1.10e+08. What is the ratio of the Aid flow (current US$) in Pacific island small states in 1994 to that in 1995?
Offer a terse response. 1.6. What is the ratio of the Aid flow (current US$) of Nepal in 1994 to that in 1995?
Ensure brevity in your answer.  0.94. What is the ratio of the Aid flow (current US$) in Panama in 1994 to that in 1995?
Your answer should be very brief. 1.04. What is the ratio of the Aid flow (current US$) in Pacific island small states in 1994 to that in 2008?
Make the answer very short. 7.1. What is the ratio of the Aid flow (current US$) in Nepal in 1994 to that in 2008?
Make the answer very short. 0.24. What is the ratio of the Aid flow (current US$) of Panama in 1994 to that in 2008?
Keep it short and to the point. 25.75. What is the ratio of the Aid flow (current US$) in Tonga in 1994 to that in 2008?
Provide a short and direct response. 0.26. What is the ratio of the Aid flow (current US$) in Pacific island small states in 1994 to that in 2009?
Offer a very short reply. 12.06. What is the ratio of the Aid flow (current US$) of Nepal in 1994 to that in 2009?
Make the answer very short. 0.23. What is the ratio of the Aid flow (current US$) of Panama in 1994 to that in 2009?
Ensure brevity in your answer.  14.71. What is the ratio of the Aid flow (current US$) of Tonga in 1994 to that in 2009?
Your answer should be very brief. 13. What is the ratio of the Aid flow (current US$) of Pacific island small states in 1994 to that in 2010?
Keep it short and to the point. 10.17. What is the ratio of the Aid flow (current US$) of Nepal in 1994 to that in 2010?
Provide a short and direct response. 0.23. What is the ratio of the Aid flow (current US$) of Panama in 1994 to that in 2010?
Your answer should be compact. 25.75. What is the ratio of the Aid flow (current US$) of Tonga in 1994 to that in 2010?
Keep it short and to the point. 0.87. What is the ratio of the Aid flow (current US$) in Pacific island small states in 1994 to that in 2011?
Keep it short and to the point. 13.11. What is the ratio of the Aid flow (current US$) in Nepal in 1994 to that in 2011?
Your response must be concise. 0.23. What is the ratio of the Aid flow (current US$) in Panama in 1994 to that in 2011?
Provide a succinct answer. 5.15. What is the ratio of the Aid flow (current US$) in Tonga in 1994 to that in 2011?
Your response must be concise. 4.33. What is the ratio of the Aid flow (current US$) in Pacific island small states in 1994 to that in 2012?
Keep it short and to the point. 8.79. What is the ratio of the Aid flow (current US$) of Nepal in 1994 to that in 2012?
Offer a very short reply. 0.22. What is the ratio of the Aid flow (current US$) in Panama in 1994 to that in 2012?
Keep it short and to the point. 1.49. What is the ratio of the Aid flow (current US$) in Tonga in 1994 to that in 2012?
Ensure brevity in your answer.  4.33. What is the ratio of the Aid flow (current US$) of Pacific island small states in 1995 to that in 2008?
Your response must be concise. 4.44. What is the ratio of the Aid flow (current US$) of Nepal in 1995 to that in 2008?
Offer a very short reply. 0.26. What is the ratio of the Aid flow (current US$) in Panama in 1995 to that in 2008?
Keep it short and to the point. 24.75. What is the ratio of the Aid flow (current US$) of Tonga in 1995 to that in 2008?
Provide a short and direct response. 0.04. What is the ratio of the Aid flow (current US$) of Pacific island small states in 1995 to that in 2009?
Ensure brevity in your answer.  7.55. What is the ratio of the Aid flow (current US$) of Nepal in 1995 to that in 2009?
Make the answer very short. 0.25. What is the ratio of the Aid flow (current US$) in Panama in 1995 to that in 2009?
Your answer should be very brief. 14.14. What is the ratio of the Aid flow (current US$) in Tonga in 1995 to that in 2009?
Keep it short and to the point. 2. What is the ratio of the Aid flow (current US$) in Pacific island small states in 1995 to that in 2010?
Offer a terse response. 6.37. What is the ratio of the Aid flow (current US$) in Nepal in 1995 to that in 2010?
Provide a succinct answer. 0.24. What is the ratio of the Aid flow (current US$) of Panama in 1995 to that in 2010?
Your response must be concise. 24.75. What is the ratio of the Aid flow (current US$) in Tonga in 1995 to that in 2010?
Make the answer very short. 0.13. What is the ratio of the Aid flow (current US$) of Pacific island small states in 1995 to that in 2011?
Your answer should be compact. 8.2. What is the ratio of the Aid flow (current US$) in Nepal in 1995 to that in 2011?
Your response must be concise. 0.25. What is the ratio of the Aid flow (current US$) of Panama in 1995 to that in 2011?
Offer a very short reply. 4.95. What is the ratio of the Aid flow (current US$) in Tonga in 1995 to that in 2011?
Your answer should be compact. 0.67. What is the ratio of the Aid flow (current US$) of Pacific island small states in 1995 to that in 2012?
Your answer should be very brief. 5.5. What is the ratio of the Aid flow (current US$) of Nepal in 1995 to that in 2012?
Provide a short and direct response. 0.23. What is the ratio of the Aid flow (current US$) of Panama in 1995 to that in 2012?
Make the answer very short. 1.43. What is the ratio of the Aid flow (current US$) in Tonga in 1995 to that in 2012?
Ensure brevity in your answer.  0.67. What is the ratio of the Aid flow (current US$) in Pacific island small states in 2008 to that in 2009?
Your response must be concise. 1.7. What is the ratio of the Aid flow (current US$) in Nepal in 2008 to that in 2009?
Your answer should be very brief. 0.96. What is the ratio of the Aid flow (current US$) in Tonga in 2008 to that in 2009?
Provide a short and direct response. 50. What is the ratio of the Aid flow (current US$) of Pacific island small states in 2008 to that in 2010?
Offer a terse response. 1.43. What is the ratio of the Aid flow (current US$) in Panama in 2008 to that in 2010?
Your answer should be compact. 1. What is the ratio of the Aid flow (current US$) in Tonga in 2008 to that in 2010?
Give a very brief answer. 3.33. What is the ratio of the Aid flow (current US$) in Pacific island small states in 2008 to that in 2011?
Offer a terse response. 1.85. What is the ratio of the Aid flow (current US$) in Nepal in 2008 to that in 2011?
Offer a very short reply. 0.95. What is the ratio of the Aid flow (current US$) in Panama in 2008 to that in 2011?
Offer a very short reply. 0.2. What is the ratio of the Aid flow (current US$) in Tonga in 2008 to that in 2011?
Provide a succinct answer. 16.67. What is the ratio of the Aid flow (current US$) in Pacific island small states in 2008 to that in 2012?
Provide a succinct answer. 1.24. What is the ratio of the Aid flow (current US$) of Nepal in 2008 to that in 2012?
Your answer should be very brief. 0.9. What is the ratio of the Aid flow (current US$) in Panama in 2008 to that in 2012?
Provide a succinct answer. 0.06. What is the ratio of the Aid flow (current US$) of Tonga in 2008 to that in 2012?
Provide a short and direct response. 16.67. What is the ratio of the Aid flow (current US$) in Pacific island small states in 2009 to that in 2010?
Offer a very short reply. 0.84. What is the ratio of the Aid flow (current US$) in Nepal in 2009 to that in 2010?
Provide a succinct answer. 0.98. What is the ratio of the Aid flow (current US$) of Tonga in 2009 to that in 2010?
Offer a terse response. 0.07. What is the ratio of the Aid flow (current US$) in Pacific island small states in 2009 to that in 2011?
Provide a succinct answer. 1.09. What is the ratio of the Aid flow (current US$) of Nepal in 2009 to that in 2011?
Offer a terse response. 0.99. What is the ratio of the Aid flow (current US$) of Pacific island small states in 2009 to that in 2012?
Keep it short and to the point. 0.73. What is the ratio of the Aid flow (current US$) of Nepal in 2009 to that in 2012?
Ensure brevity in your answer.  0.94. What is the ratio of the Aid flow (current US$) in Panama in 2009 to that in 2012?
Ensure brevity in your answer.  0.1. What is the ratio of the Aid flow (current US$) of Tonga in 2009 to that in 2012?
Provide a short and direct response. 0.33. What is the ratio of the Aid flow (current US$) of Pacific island small states in 2010 to that in 2011?
Offer a very short reply. 1.29. What is the ratio of the Aid flow (current US$) of Nepal in 2010 to that in 2011?
Provide a short and direct response. 1.01. What is the ratio of the Aid flow (current US$) of Tonga in 2010 to that in 2011?
Offer a terse response. 5. What is the ratio of the Aid flow (current US$) in Pacific island small states in 2010 to that in 2012?
Provide a succinct answer. 0.86. What is the ratio of the Aid flow (current US$) of Nepal in 2010 to that in 2012?
Make the answer very short. 0.95. What is the ratio of the Aid flow (current US$) in Panama in 2010 to that in 2012?
Ensure brevity in your answer.  0.06. What is the ratio of the Aid flow (current US$) of Pacific island small states in 2011 to that in 2012?
Your answer should be compact. 0.67. What is the ratio of the Aid flow (current US$) of Nepal in 2011 to that in 2012?
Keep it short and to the point. 0.94. What is the ratio of the Aid flow (current US$) in Panama in 2011 to that in 2012?
Your answer should be compact. 0.29. What is the ratio of the Aid flow (current US$) in Tonga in 2011 to that in 2012?
Keep it short and to the point. 1. What is the difference between the highest and the second highest Aid flow (current US$) in Pacific island small states?
Your response must be concise. 5.10e+06. What is the difference between the highest and the second highest Aid flow (current US$) of Nepal?
Offer a very short reply. 4.96e+06. What is the difference between the highest and the second highest Aid flow (current US$) of Panama?
Your answer should be very brief. 4.00e+04. What is the difference between the highest and the second highest Aid flow (current US$) of Tonga?
Provide a short and direct response. 3.50e+05. What is the difference between the highest and the lowest Aid flow (current US$) of Pacific island small states?
Make the answer very short. 1.26e+07. What is the difference between the highest and the lowest Aid flow (current US$) in Nepal?
Make the answer very short. 8.62e+07. What is the difference between the highest and the lowest Aid flow (current US$) of Panama?
Your response must be concise. 9.90e+05. 